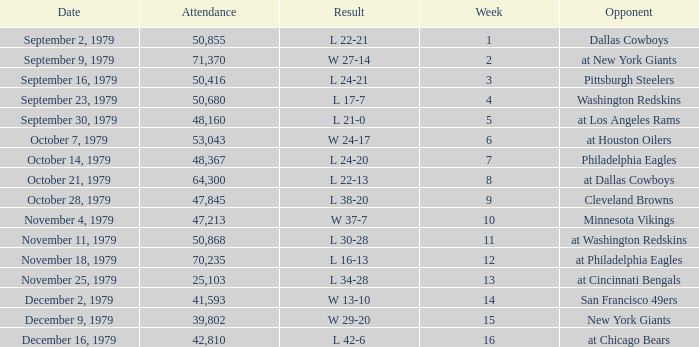What result in a week over 2 occurred with an attendance greater than 53,043 on November 18, 1979? L 16-13. 